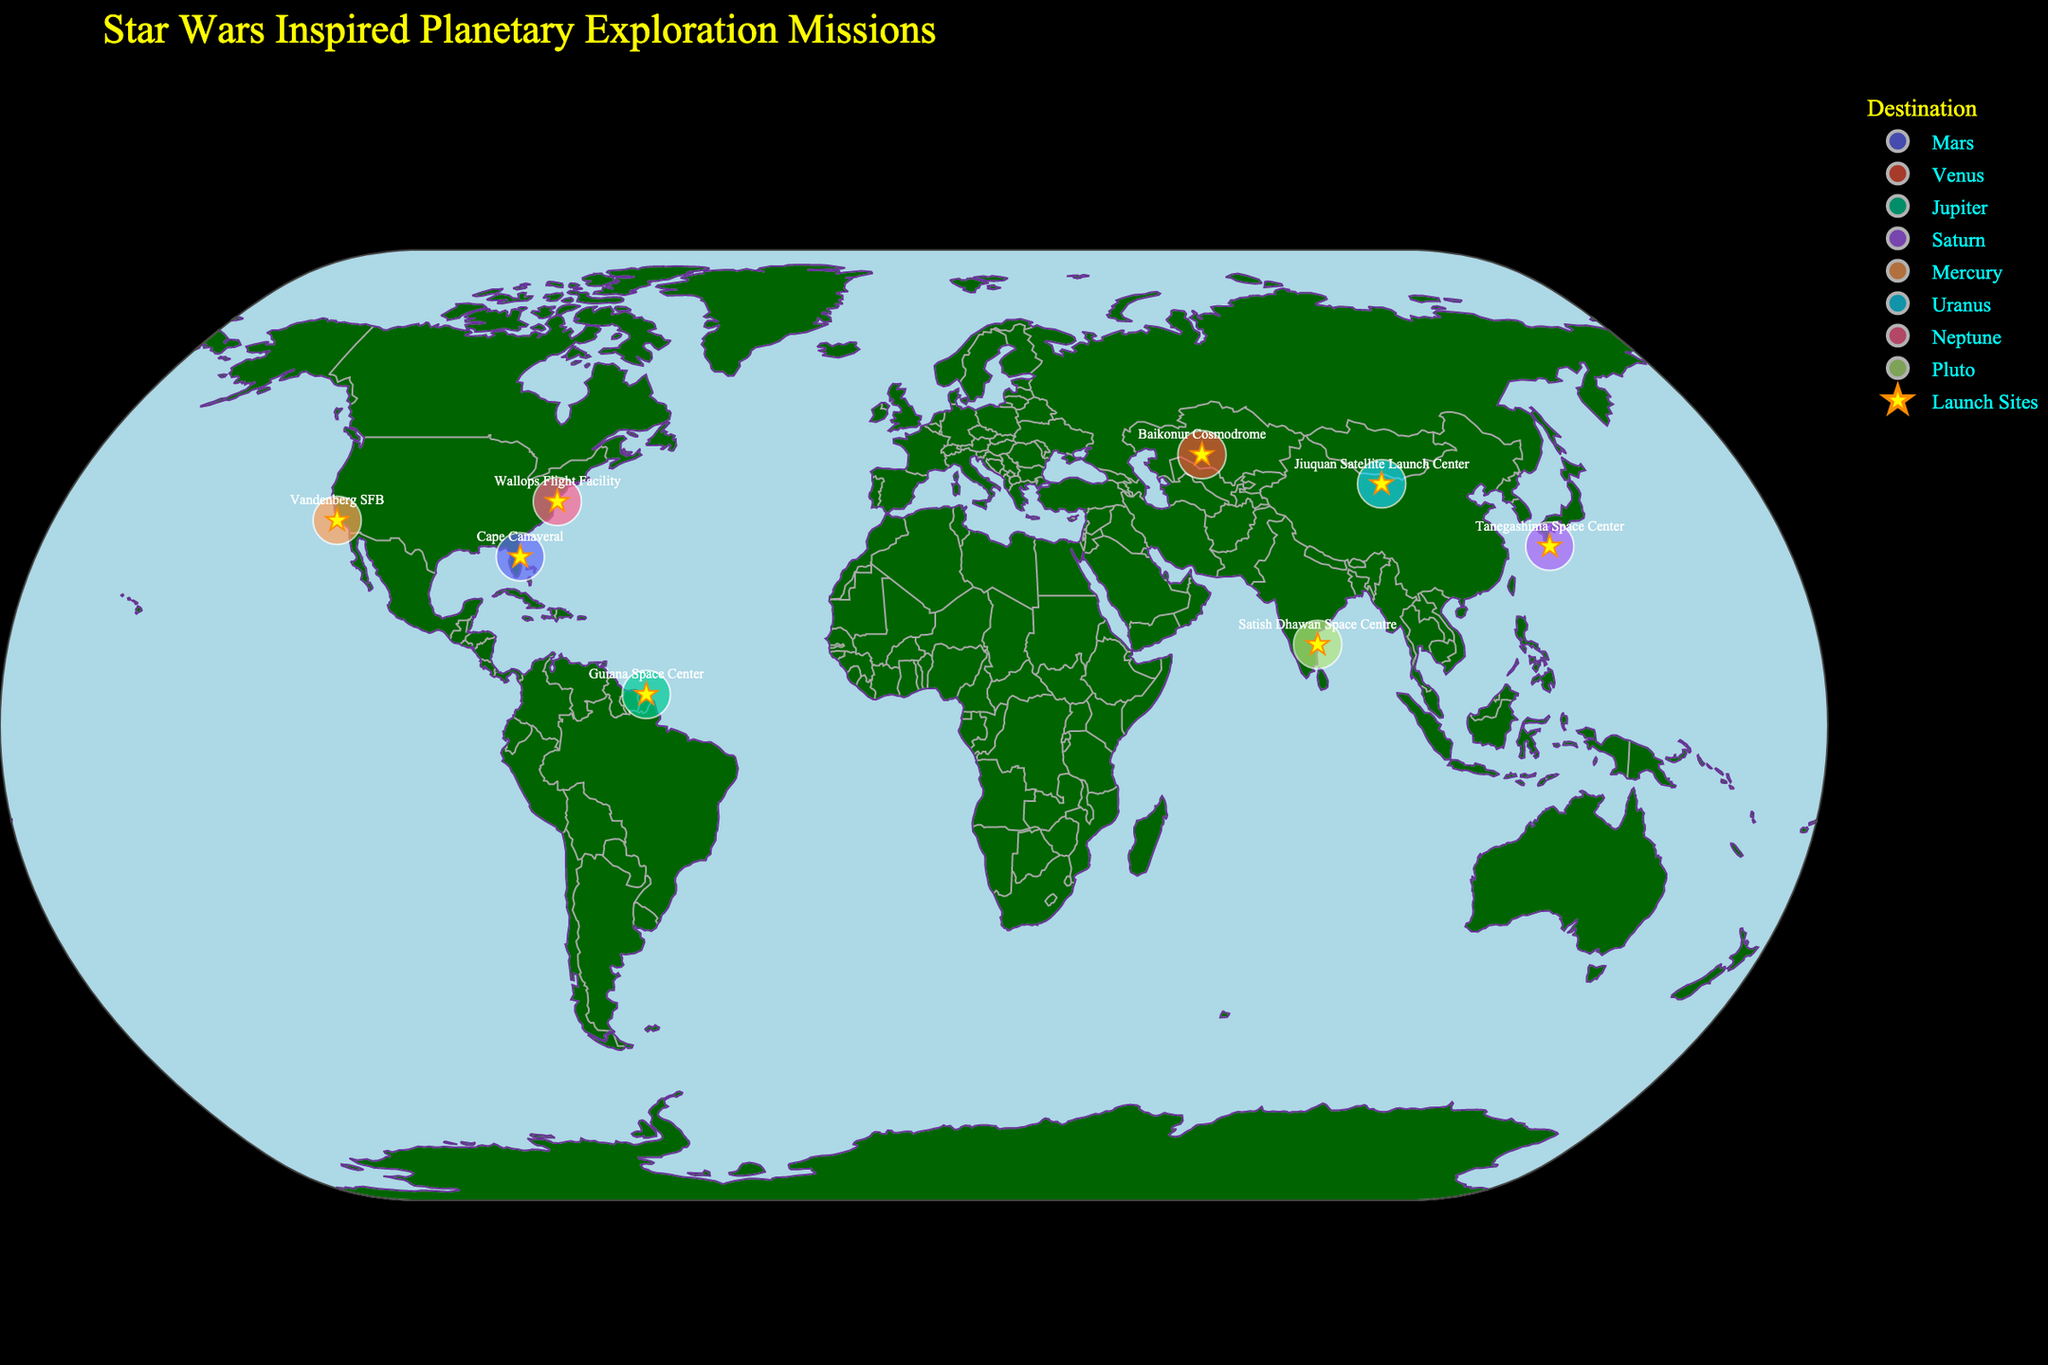What's the title of the figure? The title is typically found at the top of the figure. In this case, it is clearly stated and designed with a distinctive font.
Answer: Star Wars Inspired Planetary Exploration Missions How many launch sites are depicted in the figure? Each launch site is represented by a unique star symbol on the map. By visually counting the stars, we determine the number of launch sites.
Answer: 8 Which two missions are launched from the launch sites closest in latitude to each other? We compare the latitudes of all launch sites and find the pair that are closest. Tanegashima Space Center (30.3542) and Cape Canaveral (28.5729) are the closest. The missions from these sites are X-wing Explorer and Jedi Knight respectively.
Answer: X-wing Explorer and Jedi Knight Among the destinations, which planet is associated with the earliest mission year? Look at the hover data for each mission to determine the destination and year. The earliest mission is in 2025, which is headed to Mars.
Answer: Mars What is the average year of the missions launched from the sites with latitudes above 35 degrees? Filter the launch sites with latitudes above 35 degrees and then average their mission years. These sites are Baikonur Cosmodrome (2027), Vandenberg SFB (2026), Jiuquan Satellite Launch Center (2030), and Wallops Flight Facility (2028). The average is (2027 + 2026 + 2030 + 2028) / 4 = 2027.75
Answer: 2027.75 Which launch site has the furthest distance from the equator? Examine the latitude values and pick the launch site with the highest absolute value. Jiuquan Satellite Launch Center (40.9583) is the furthest from the equator.
Answer: Jiuquan Satellite Launch Center Is there a mission targeted to an ice giant? If so, what is the mission name and its destination? Ice giants are Uranus and Neptune. Check the hover data for missions targeting these planets. The mission names are Rebel Alliance Scout to Neptune and Death Star Surveyor to Uranus.
Answer: Death Star Surveyor and Rebel Alliance Scout Which launch site sends a mission to Saturn, and in what year is it scheduled? Identify the destination Saturn in the hover data and note the corresponding launch site and year. The site is Tanegashima Space Center, and the year is 2031.
Answer: Tanegashima Space Center, 2031 What is the total number of missions planned between the years 2027 and 2031 inclusive? Count the number of missions within the years 2027, 2028, 2029, 2030, and 2031. Baikonur Cosmodrome (2027), Wallops Flight Facility (2028), Guiana Space Center (2029), Jiuquan Satellite Launch Center (2030), and Tanegashima Space Center (2031) are the missions. There are 5 in total.
Answer: 5 